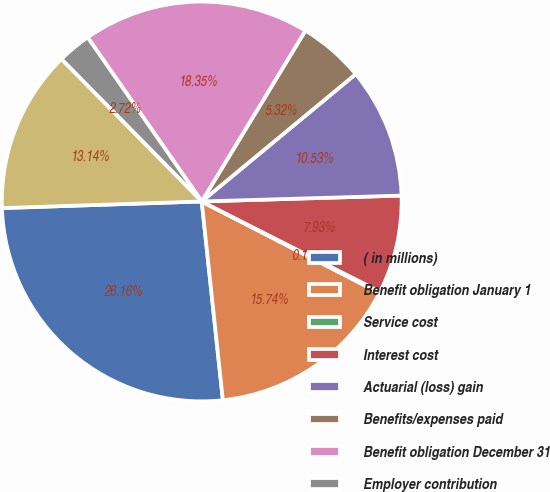Convert chart. <chart><loc_0><loc_0><loc_500><loc_500><pie_chart><fcel>( in millions)<fcel>Benefit obligation January 1<fcel>Service cost<fcel>Interest cost<fcel>Actuarial (loss) gain<fcel>Benefits/expenses paid<fcel>Benefit obligation December 31<fcel>Employer contribution<fcel>Funded status at end of year<nl><fcel>26.16%<fcel>15.74%<fcel>0.11%<fcel>7.93%<fcel>10.53%<fcel>5.32%<fcel>18.35%<fcel>2.72%<fcel>13.14%<nl></chart> 